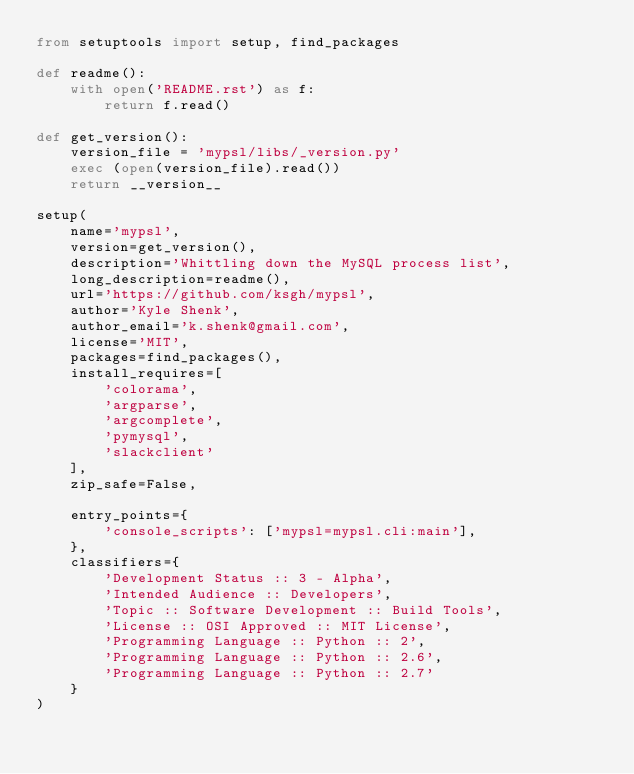Convert code to text. <code><loc_0><loc_0><loc_500><loc_500><_Python_>from setuptools import setup, find_packages

def readme():
    with open('README.rst') as f:
        return f.read()

def get_version():
    version_file = 'mypsl/libs/_version.py'
    exec (open(version_file).read())
    return __version__

setup(
    name='mypsl',
    version=get_version(),
    description='Whittling down the MySQL process list',
    long_description=readme(),
    url='https://github.com/ksgh/mypsl',
    author='Kyle Shenk',
    author_email='k.shenk@gmail.com',
    license='MIT',
    packages=find_packages(),
    install_requires=[
        'colorama',
        'argparse',
        'argcomplete',
        'pymysql',
        'slackclient'
    ],
    zip_safe=False,

    entry_points={
        'console_scripts': ['mypsl=mypsl.cli:main'],
    },
    classifiers={
        'Development Status :: 3 - Alpha',
        'Intended Audience :: Developers',
        'Topic :: Software Development :: Build Tools',
        'License :: OSI Approved :: MIT License',
        'Programming Language :: Python :: 2',
        'Programming Language :: Python :: 2.6',
        'Programming Language :: Python :: 2.7'
    }
)</code> 